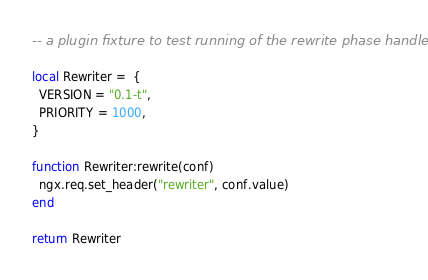<code> <loc_0><loc_0><loc_500><loc_500><_Lua_>-- a plugin fixture to test running of the rewrite phase handler.

local Rewriter =  {
  VERSION = "0.1-t",
  PRIORITY = 1000,
}

function Rewriter:rewrite(conf)
  ngx.req.set_header("rewriter", conf.value)
end

return Rewriter
</code> 